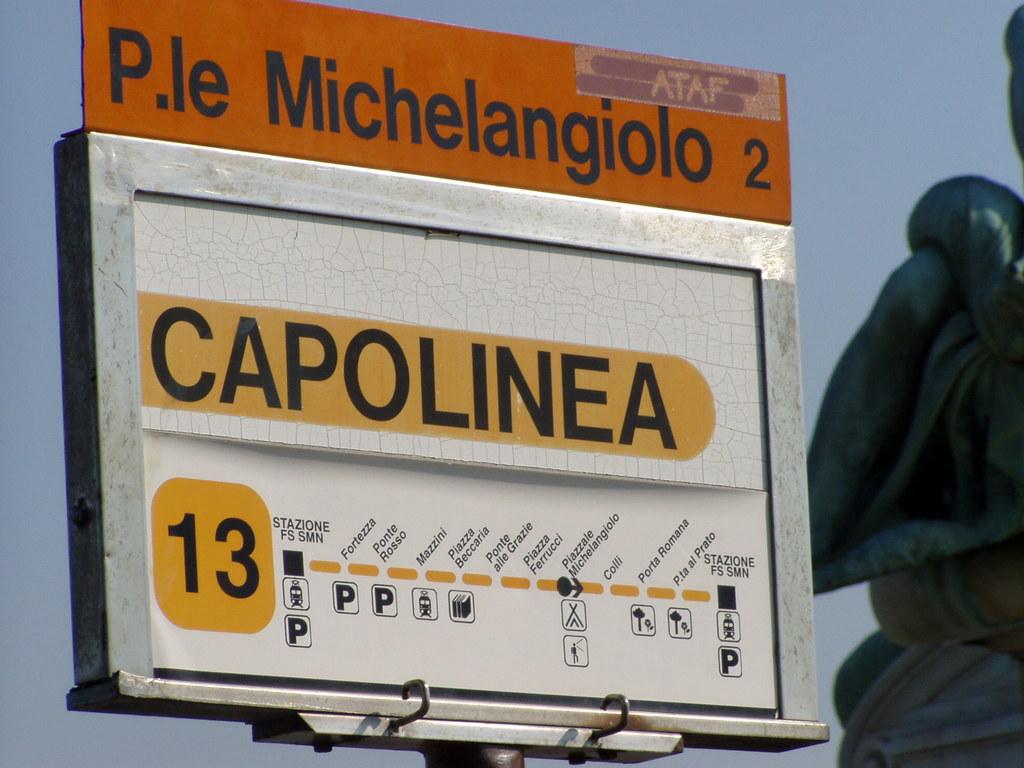What does the ad say?
Your response must be concise. Capolinea. What is the first stop after leaving the station?
Provide a succinct answer. Fortezza. 